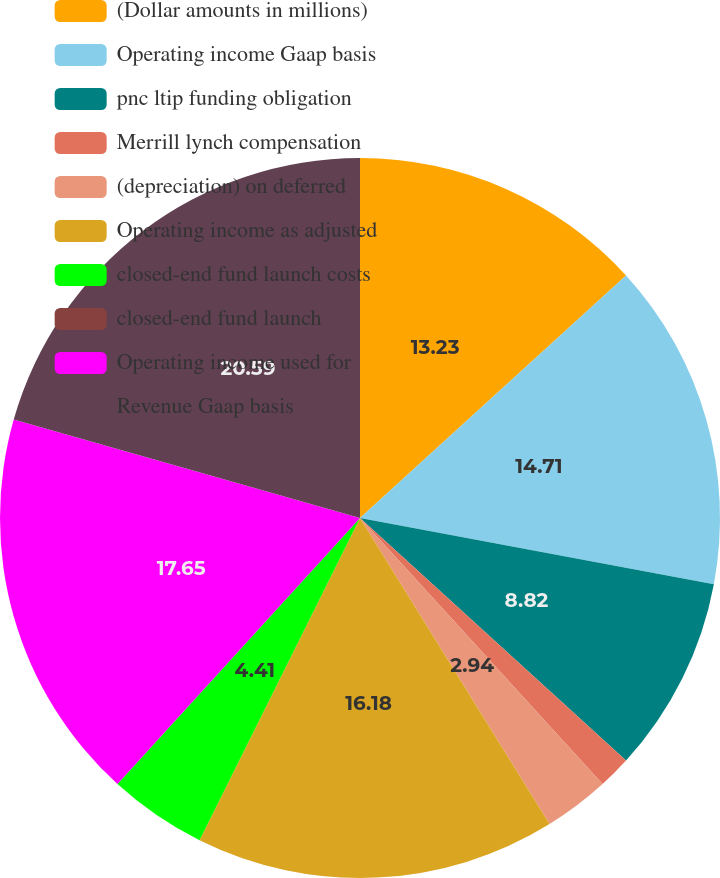Convert chart. <chart><loc_0><loc_0><loc_500><loc_500><pie_chart><fcel>(Dollar amounts in millions)<fcel>Operating income Gaap basis<fcel>pnc ltip funding obligation<fcel>Merrill lynch compensation<fcel>(depreciation) on deferred<fcel>Operating income as adjusted<fcel>closed-end fund launch costs<fcel>closed-end fund launch<fcel>Operating income used for<fcel>Revenue Gaap basis<nl><fcel>13.23%<fcel>14.7%<fcel>8.82%<fcel>1.47%<fcel>2.94%<fcel>16.17%<fcel>4.41%<fcel>0.0%<fcel>17.64%<fcel>20.58%<nl></chart> 